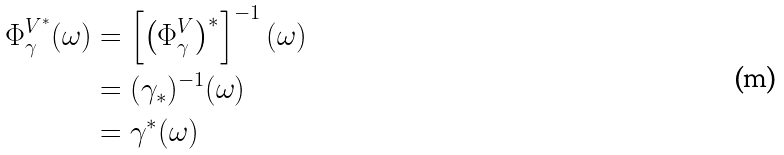Convert formula to latex. <formula><loc_0><loc_0><loc_500><loc_500>\Phi _ { \gamma } ^ { V ^ { \ast } } ( \omega ) & = \left [ \left ( \Phi _ { \gamma } ^ { V } \right ) ^ { \ast } \right ] ^ { - 1 } ( \omega ) \\ & = ( \gamma _ { \ast } ) ^ { - 1 } ( \omega ) \\ & = \gamma ^ { \ast } ( \omega )</formula> 